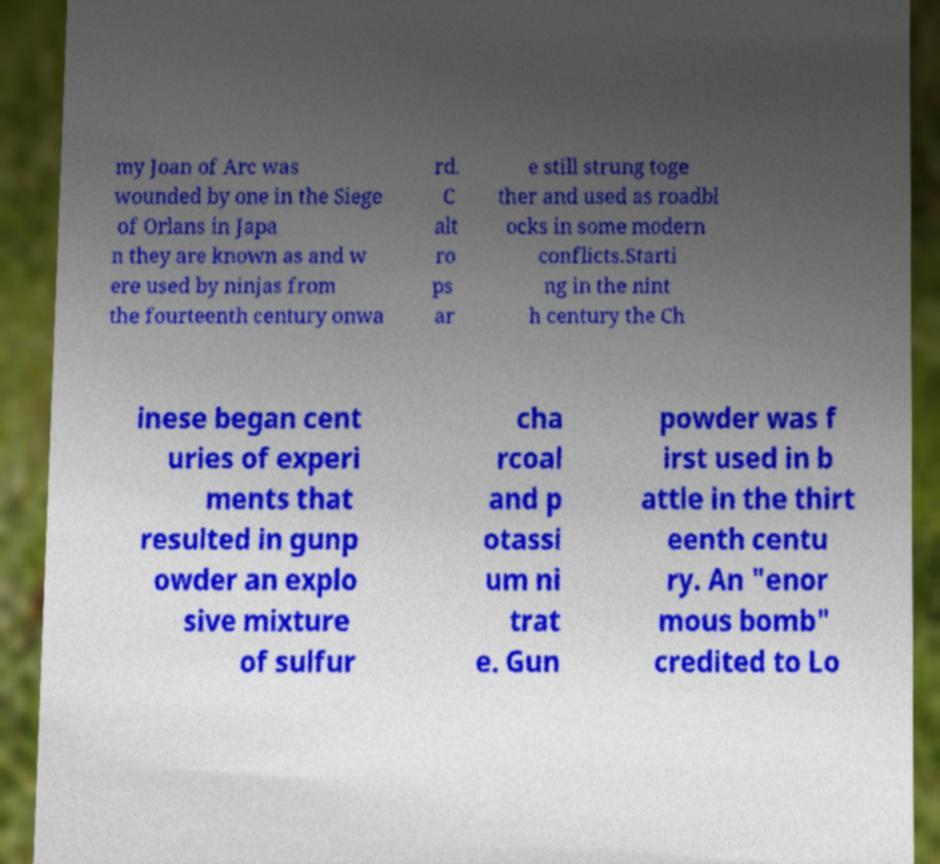There's text embedded in this image that I need extracted. Can you transcribe it verbatim? my Joan of Arc was wounded by one in the Siege of Orlans in Japa n they are known as and w ere used by ninjas from the fourteenth century onwa rd. C alt ro ps ar e still strung toge ther and used as roadbl ocks in some modern conflicts.Starti ng in the nint h century the Ch inese began cent uries of experi ments that resulted in gunp owder an explo sive mixture of sulfur cha rcoal and p otassi um ni trat e. Gun powder was f irst used in b attle in the thirt eenth centu ry. An "enor mous bomb" credited to Lo 